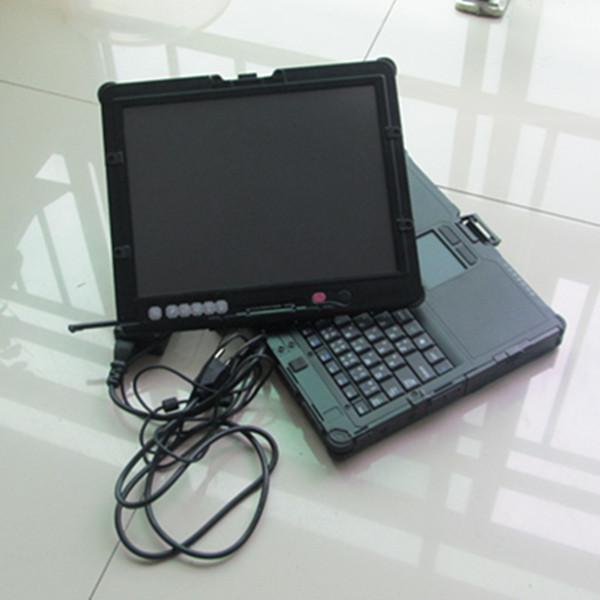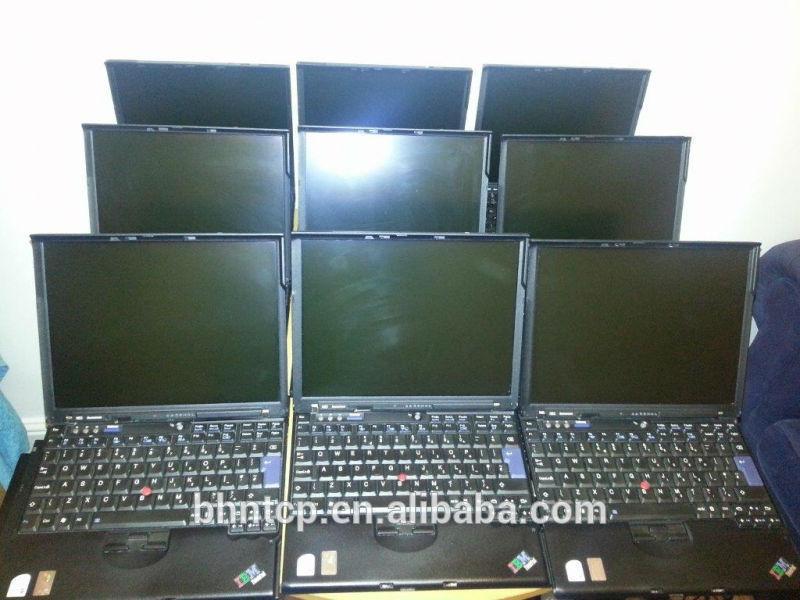The first image is the image on the left, the second image is the image on the right. Considering the images on both sides, is "An image shows rows of lap stocks arranged three across." valid? Answer yes or no. Yes. The first image is the image on the left, the second image is the image on the right. Assess this claim about the two images: "In one image, laptop computers are lined in rows three across, with at least the first row fully open.". Correct or not? Answer yes or no. Yes. 